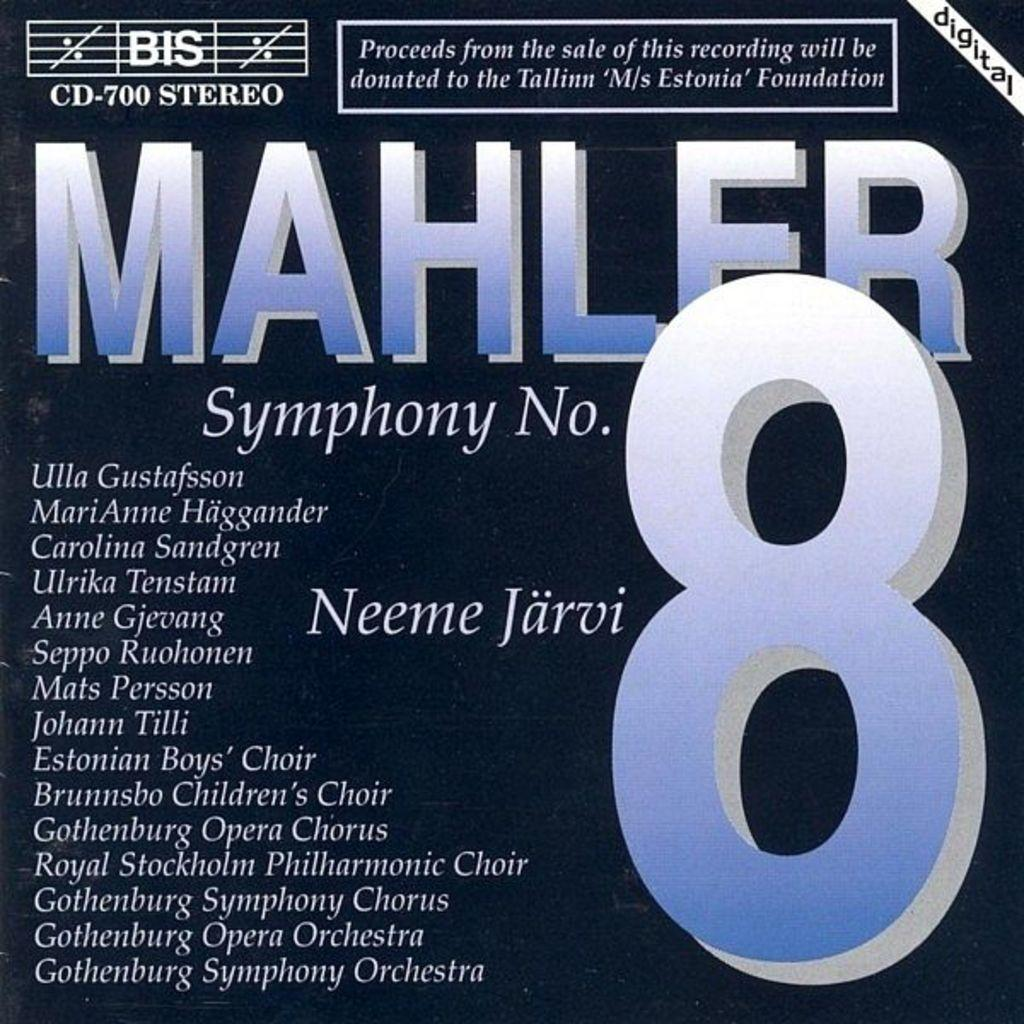<image>
Relay a brief, clear account of the picture shown. Mahler Symphony No. 8 displays a list of names. 